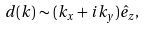Convert formula to latex. <formula><loc_0><loc_0><loc_500><loc_500>d ( k ) \sim ( k _ { x } + i k _ { y } ) \hat { e } _ { z } ,</formula> 